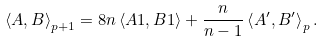<formula> <loc_0><loc_0><loc_500><loc_500>\left \langle A , B \right \rangle _ { p + 1 } = 8 n \left \langle A 1 , B 1 \right \rangle + \frac { n } { n - 1 } \left \langle A ^ { \prime } , B ^ { \prime } \right \rangle _ { p } .</formula> 